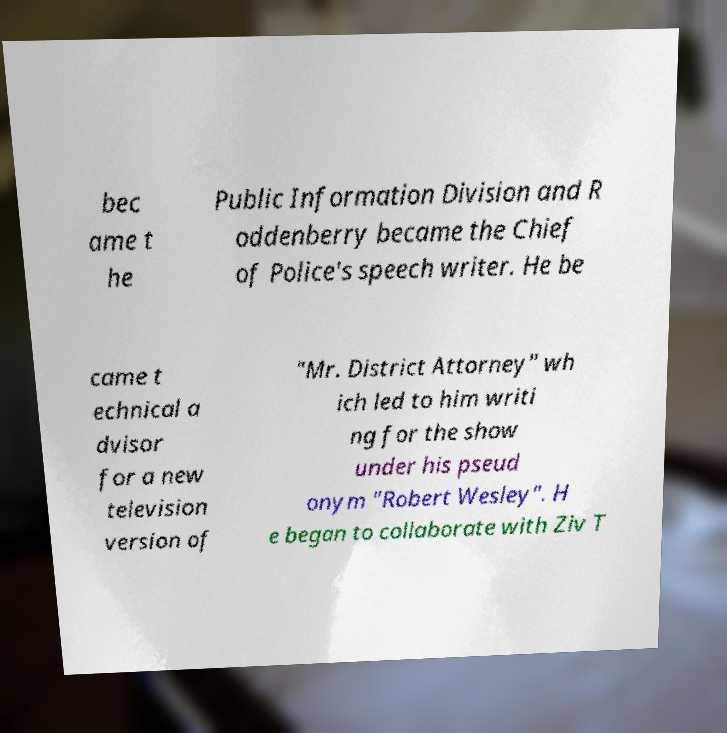There's text embedded in this image that I need extracted. Can you transcribe it verbatim? bec ame t he Public Information Division and R oddenberry became the Chief of Police's speech writer. He be came t echnical a dvisor for a new television version of "Mr. District Attorney" wh ich led to him writi ng for the show under his pseud onym "Robert Wesley". H e began to collaborate with Ziv T 